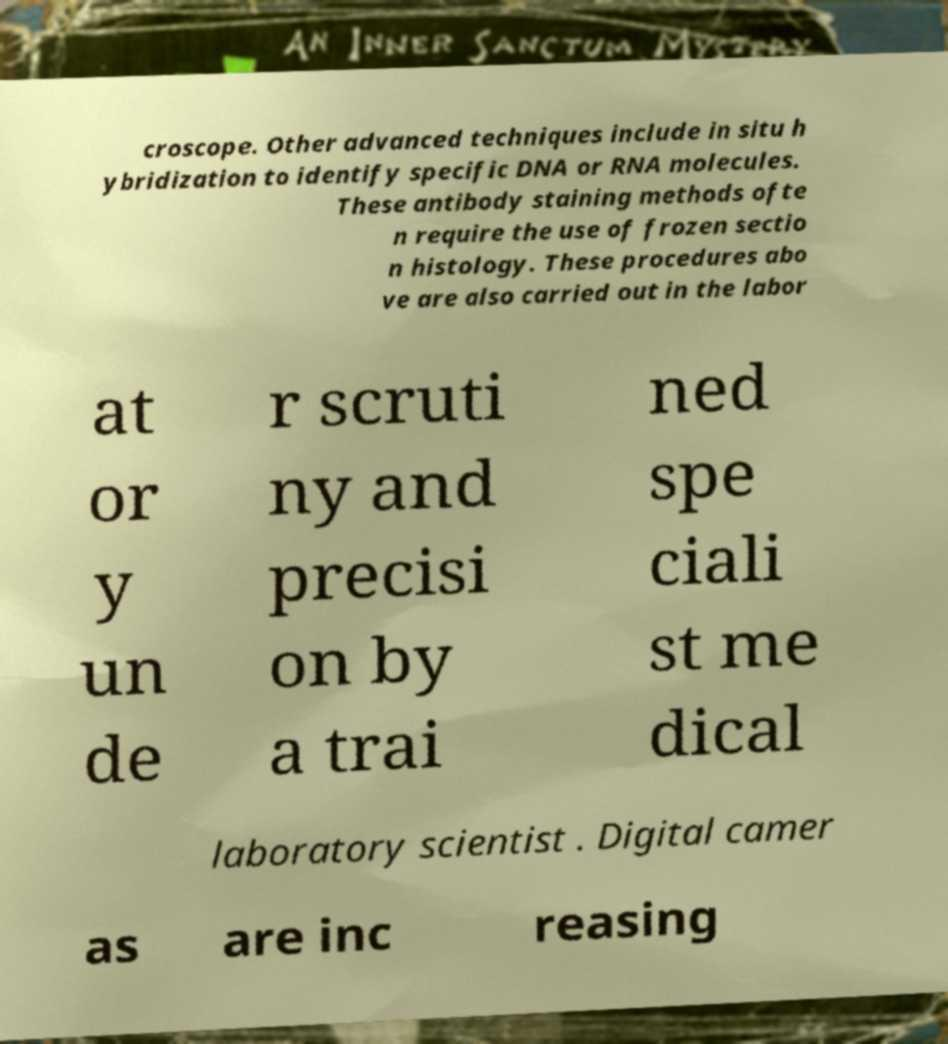Can you accurately transcribe the text from the provided image for me? croscope. Other advanced techniques include in situ h ybridization to identify specific DNA or RNA molecules. These antibody staining methods ofte n require the use of frozen sectio n histology. These procedures abo ve are also carried out in the labor at or y un de r scruti ny and precisi on by a trai ned spe ciali st me dical laboratory scientist . Digital camer as are inc reasing 